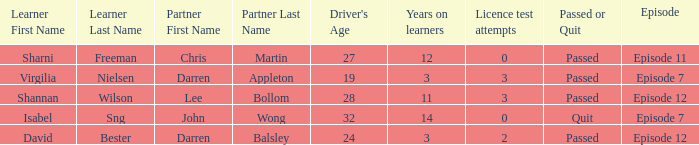What is the average number of years on learners of the drivers over the age of 24 with less than 0 attempts at the licence test? None. 